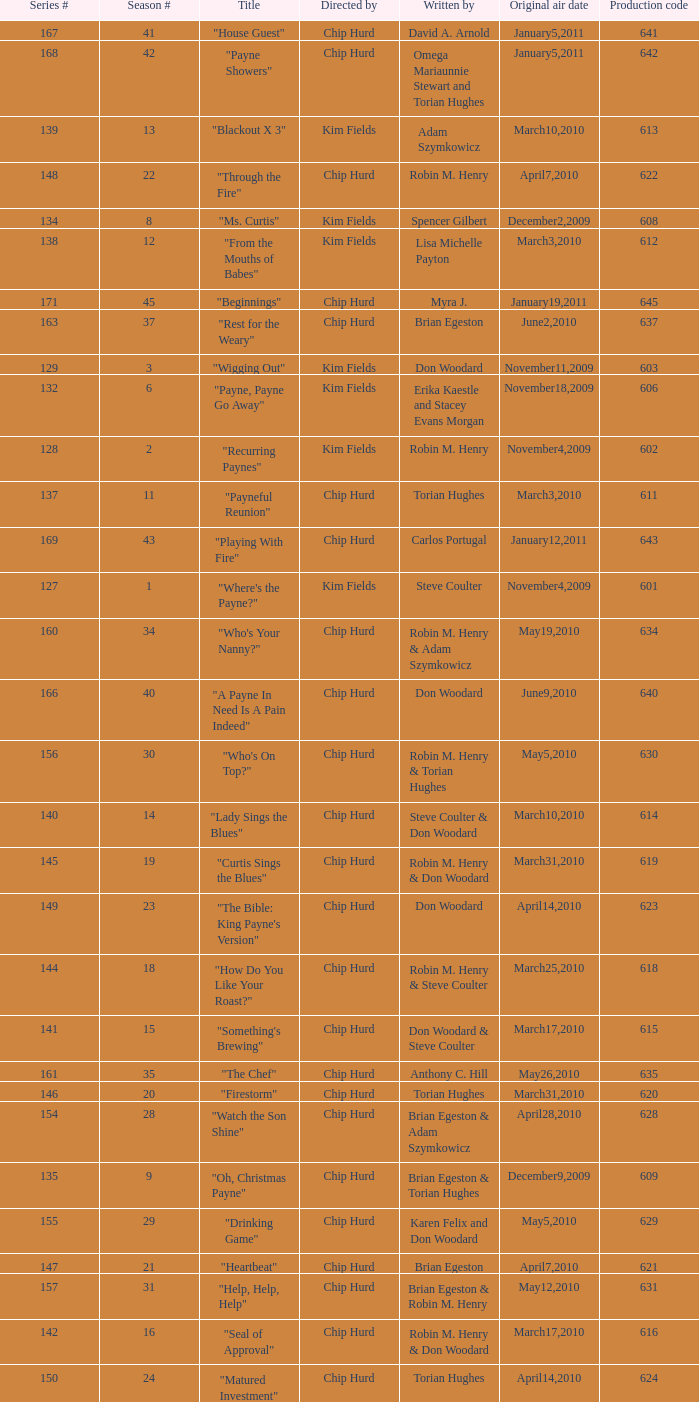What is the original air dates for the title "firestorm"? March31,2010. Help me parse the entirety of this table. {'header': ['Series #', 'Season #', 'Title', 'Directed by', 'Written by', 'Original air date', 'Production code'], 'rows': [['167', '41', '"House Guest"', 'Chip Hurd', 'David A. Arnold', 'January5,2011', '641'], ['168', '42', '"Payne Showers"', 'Chip Hurd', 'Omega Mariaunnie Stewart and Torian Hughes', 'January5,2011', '642'], ['139', '13', '"Blackout X 3"', 'Kim Fields', 'Adam Szymkowicz', 'March10,2010', '613'], ['148', '22', '"Through the Fire"', 'Chip Hurd', 'Robin M. Henry', 'April7,2010', '622'], ['134', '8', '"Ms. Curtis"', 'Kim Fields', 'Spencer Gilbert', 'December2,2009', '608'], ['138', '12', '"From the Mouths of Babes"', 'Kim Fields', 'Lisa Michelle Payton', 'March3,2010', '612'], ['171', '45', '"Beginnings"', 'Chip Hurd', 'Myra J.', 'January19,2011', '645'], ['163', '37', '"Rest for the Weary"', 'Chip Hurd', 'Brian Egeston', 'June2,2010', '637'], ['129', '3', '"Wigging Out"', 'Kim Fields', 'Don Woodard', 'November11,2009', '603'], ['132', '6', '"Payne, Payne Go Away"', 'Kim Fields', 'Erika Kaestle and Stacey Evans Morgan', 'November18,2009', '606'], ['128', '2', '"Recurring Paynes"', 'Kim Fields', 'Robin M. Henry', 'November4,2009', '602'], ['137', '11', '"Payneful Reunion"', 'Chip Hurd', 'Torian Hughes', 'March3,2010', '611'], ['169', '43', '"Playing With Fire"', 'Chip Hurd', 'Carlos Portugal', 'January12,2011', '643'], ['127', '1', '"Where\'s the Payne?"', 'Kim Fields', 'Steve Coulter', 'November4,2009', '601'], ['160', '34', '"Who\'s Your Nanny?"', 'Chip Hurd', 'Robin M. Henry & Adam Szymkowicz', 'May19,2010', '634'], ['166', '40', '"A Payne In Need Is A Pain Indeed"', 'Chip Hurd', 'Don Woodard', 'June9,2010', '640'], ['156', '30', '"Who\'s On Top?"', 'Chip Hurd', 'Robin M. Henry & Torian Hughes', 'May5,2010', '630'], ['140', '14', '"Lady Sings the Blues"', 'Chip Hurd', 'Steve Coulter & Don Woodard', 'March10,2010', '614'], ['145', '19', '"Curtis Sings the Blues"', 'Chip Hurd', 'Robin M. Henry & Don Woodard', 'March31,2010', '619'], ['149', '23', '"The Bible: King Payne\'s Version"', 'Chip Hurd', 'Don Woodard', 'April14,2010', '623'], ['144', '18', '"How Do You Like Your Roast?"', 'Chip Hurd', 'Robin M. Henry & Steve Coulter', 'March25,2010', '618'], ['141', '15', '"Something\'s Brewing"', 'Chip Hurd', 'Don Woodard & Steve Coulter', 'March17,2010', '615'], ['161', '35', '"The Chef"', 'Chip Hurd', 'Anthony C. Hill', 'May26,2010', '635'], ['146', '20', '"Firestorm"', 'Chip Hurd', 'Torian Hughes', 'March31,2010', '620'], ['154', '28', '"Watch the Son Shine"', 'Chip Hurd', 'Brian Egeston & Adam Szymkowicz', 'April28,2010', '628'], ['135', '9', '"Oh, Christmas Payne"', 'Chip Hurd', 'Brian Egeston & Torian Hughes', 'December9,2009', '609'], ['155', '29', '"Drinking Game"', 'Chip Hurd', 'Karen Felix and Don Woodard', 'May5,2010', '629'], ['147', '21', '"Heartbeat"', 'Chip Hurd', 'Brian Egeston', 'April7,2010', '621'], ['157', '31', '"Help, Help, Help"', 'Chip Hurd', 'Brian Egeston & Robin M. Henry', 'May12,2010', '631'], ['142', '16', '"Seal of Approval"', 'Chip Hurd', 'Robin M. Henry & Don Woodard', 'March17,2010', '616'], ['150', '24', '"Matured Investment"', 'Chip Hurd', 'Torian Hughes', 'April14,2010', '624'], ['136', '10', '"Til Payne Do We Part"', 'Chip Hurd', 'Adam Szymkowicz', 'December23,2009', '610'], ['158', '32', '"Stinging Payne"', 'Chip Hurd', 'Don Woodard', 'May12,2010', '632'], ['152', '26', '"Feet of Clay"', 'Chip Hurd', 'Don Woodard', 'April21,2010', '626'], ['164', '38', '"Thug Life"', 'Chip Hurd', 'Torian Hughes', 'June2,2010', '638'], ['151', '25', '"Who\'s Your Daddy Now?"', 'Chip Hurd', 'Brian Egeston', 'April21,2010', '625'], ['162', '36', '"My Fair Curtis"', 'Chip Hurd', 'Don Woodard', 'May26,2010', '636'], ['153', '27', '"Date Night x 3"', 'Chip Hurd', 'Adam Szymkowicz', 'April28,2010', '627'], ['159', '33', '"Worth Fighting For"', 'Chip Hurd', 'Torian Hughes', 'May19,2010', '633'], ['133', '7', '"Marriage Paynes"', 'Kim Fields', 'Daniel Beaty and Stacey Evans Morgan', 'November25,2009', '607'], ['143', '17', '"Payneful Pie"', 'Chip Hurd', 'Kellie Zimmerman-Green', 'March25,2010', '617'], ['130', '4', '"Payne Speaking"', 'Kim Fields', 'Don Woodard', 'November11,2009', '604'], ['170', '44', '"When the Payne\'s Away"', 'Chip Hurd', 'Kristin Topps and Don Woodard', 'January12,2011', '644'], ['165', '39', '"Rehabilitation"', 'Chip Hurd', 'Adam Szymkowicz', 'June9,2010', '639'], ['131', '5', '"Parental Payne"', 'Kim Fields', 'Brian Egeston', 'November18,2009', '605']]} 